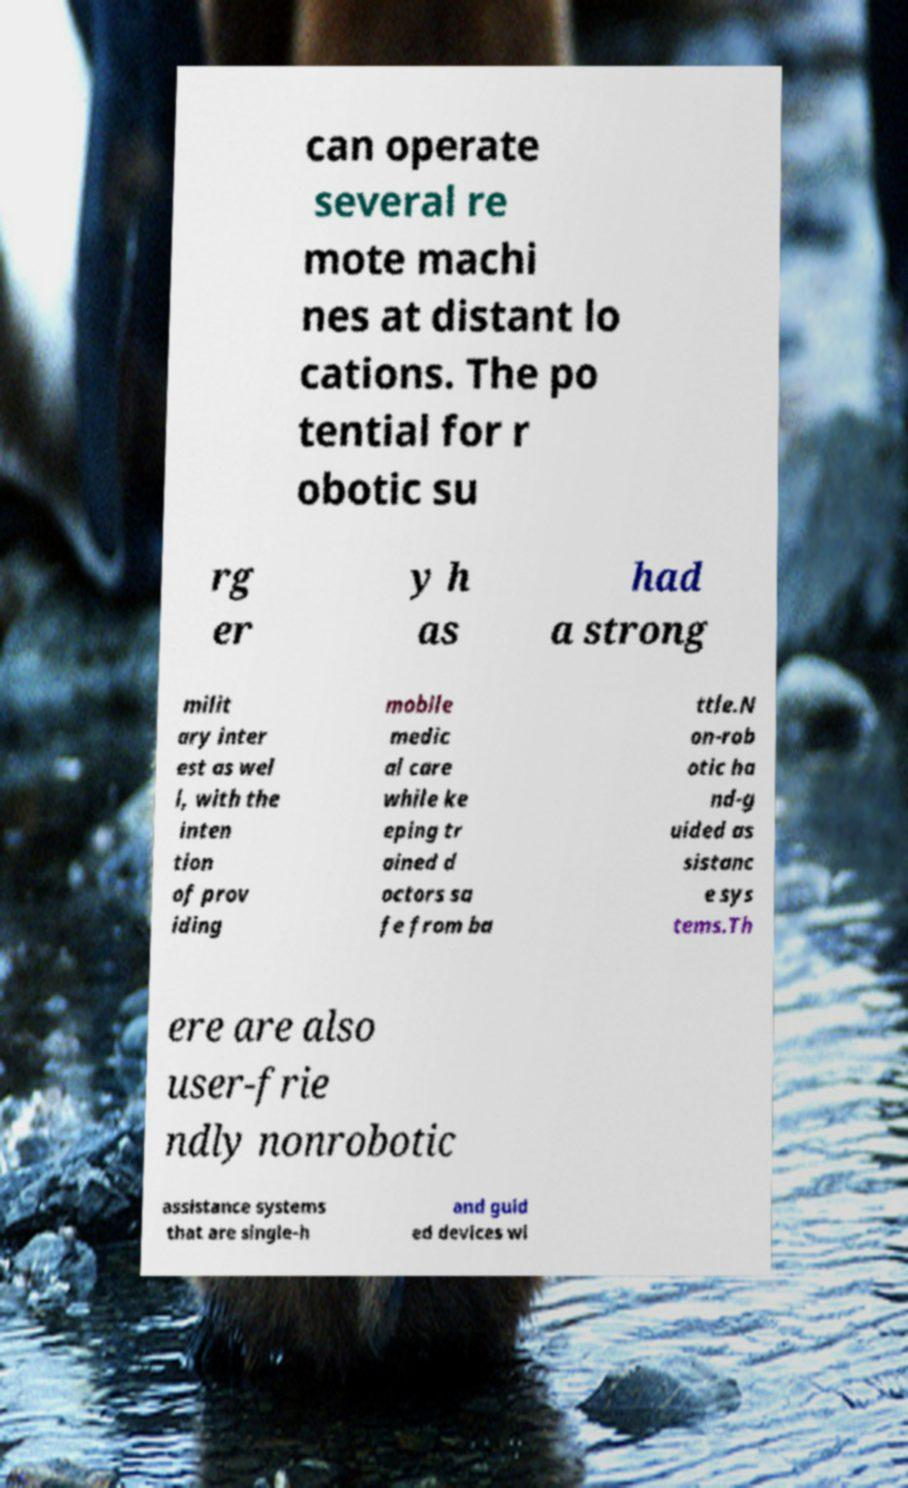Can you read and provide the text displayed in the image?This photo seems to have some interesting text. Can you extract and type it out for me? can operate several re mote machi nes at distant lo cations. The po tential for r obotic su rg er y h as had a strong milit ary inter est as wel l, with the inten tion of prov iding mobile medic al care while ke eping tr ained d octors sa fe from ba ttle.N on-rob otic ha nd-g uided as sistanc e sys tems.Th ere are also user-frie ndly nonrobotic assistance systems that are single-h and guid ed devices wi 